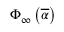Convert formula to latex. <formula><loc_0><loc_0><loc_500><loc_500>\Phi _ { \infty } \left ( \overline { \alpha } \right )</formula> 